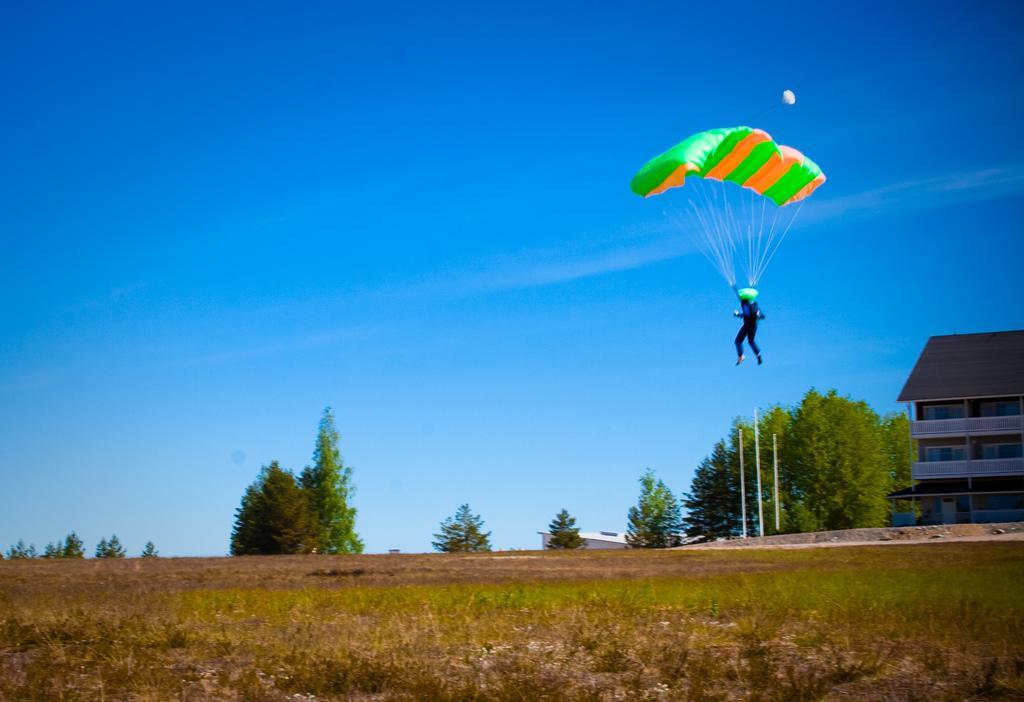How would you summarize this image in a sentence or two? In this image we can see there is a parachute in the air. On the right side of the image there is a building, beside the building there are some trees. In the background there is a sky. 